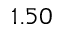<formula> <loc_0><loc_0><loc_500><loc_500>1 . 5 0</formula> 